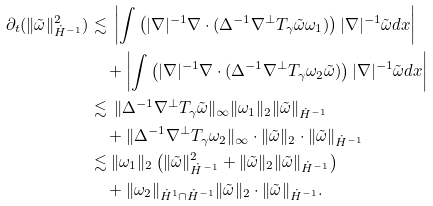<formula> <loc_0><loc_0><loc_500><loc_500>\partial _ { t } ( \| \tilde { \omega } \| ^ { 2 } _ { \dot { H } ^ { - 1 } } ) & \lesssim \, \left | \int \left ( | \nabla | ^ { - 1 } \nabla \cdot ( \Delta ^ { - 1 } \nabla ^ { \perp } T _ { \gamma } \tilde { \omega } \omega _ { 1 } ) \right ) | \nabla | ^ { - 1 } \tilde { \omega } d x \right | \\ & \quad + \left | \int \left ( | \nabla | ^ { - 1 } \nabla \cdot ( \Delta ^ { - 1 } \nabla ^ { \perp } T _ { \gamma } \omega _ { 2 } \tilde { \omega } ) \right ) | \nabla | ^ { - 1 } \tilde { \omega } d x \right | \\ & \lesssim \, \| \Delta ^ { - 1 } \nabla ^ { \perp } T _ { \gamma } \tilde { \omega } \| _ { \infty } \| \omega _ { 1 } \| _ { 2 } \| \tilde { \omega } \| _ { \dot { H } ^ { - 1 } } \\ & \quad + \| \Delta ^ { - 1 } \nabla ^ { \perp } T _ { \gamma } \omega _ { 2 } \| _ { \infty } \cdot \| \tilde { \omega } \| _ { 2 } \cdot \| \tilde { \omega } \| _ { \dot { H } ^ { - 1 } } \\ & \lesssim \| \omega _ { 1 } \| _ { 2 } \left ( \| \tilde { \omega } \| ^ { 2 } _ { \dot { H } ^ { - 1 } } + \| \tilde { \omega } \| _ { 2 } \| \tilde { \omega } \| _ { \dot { H } ^ { - 1 } } \right ) \\ & \quad + \| \omega _ { 2 } \| _ { \dot { H } ^ { 1 } \cap \dot { H } ^ { - 1 } } \| \tilde { \omega } \| _ { 2 } \cdot \| \tilde { \omega } \| _ { \dot { H } ^ { - 1 } } .</formula> 